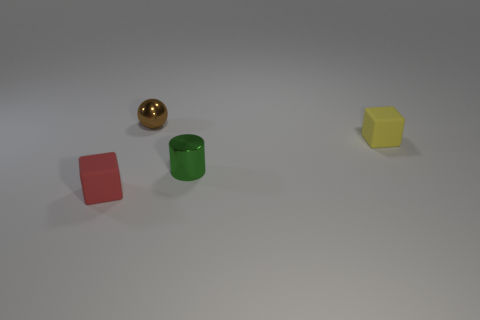Add 1 yellow objects. How many objects exist? 5 Subtract all cylinders. How many objects are left? 3 Add 2 yellow matte objects. How many yellow matte objects are left? 3 Add 4 gray rubber cubes. How many gray rubber cubes exist? 4 Subtract 0 green cubes. How many objects are left? 4 Subtract all small red things. Subtract all large blue metallic objects. How many objects are left? 3 